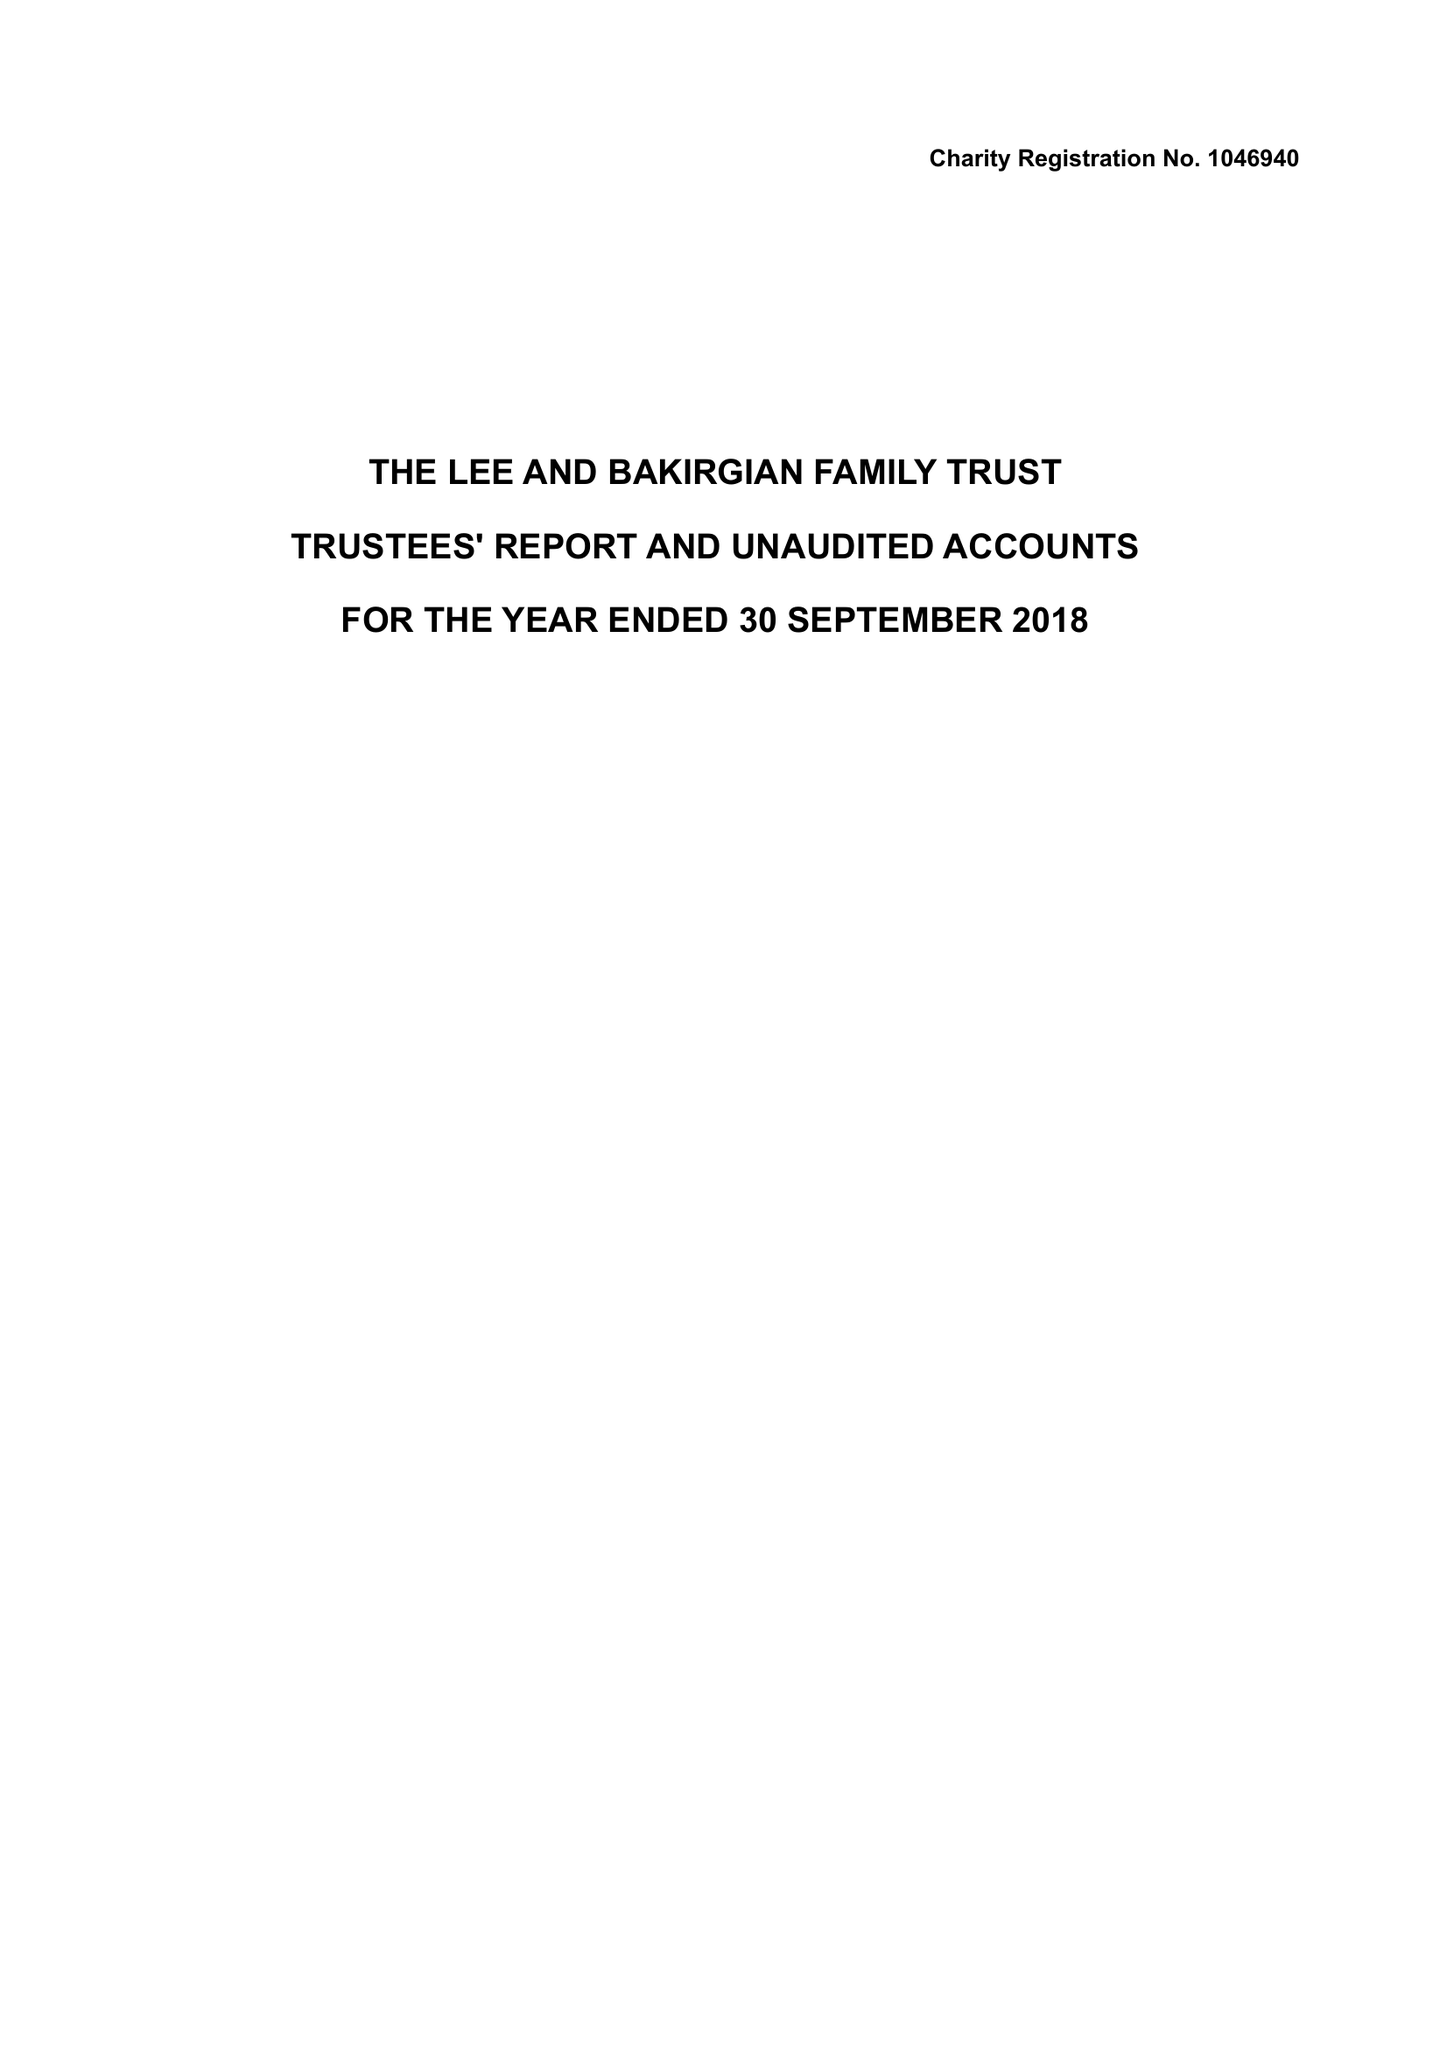What is the value for the charity_name?
Answer the question using a single word or phrase. The Lee and Bakirgian Family Trust 